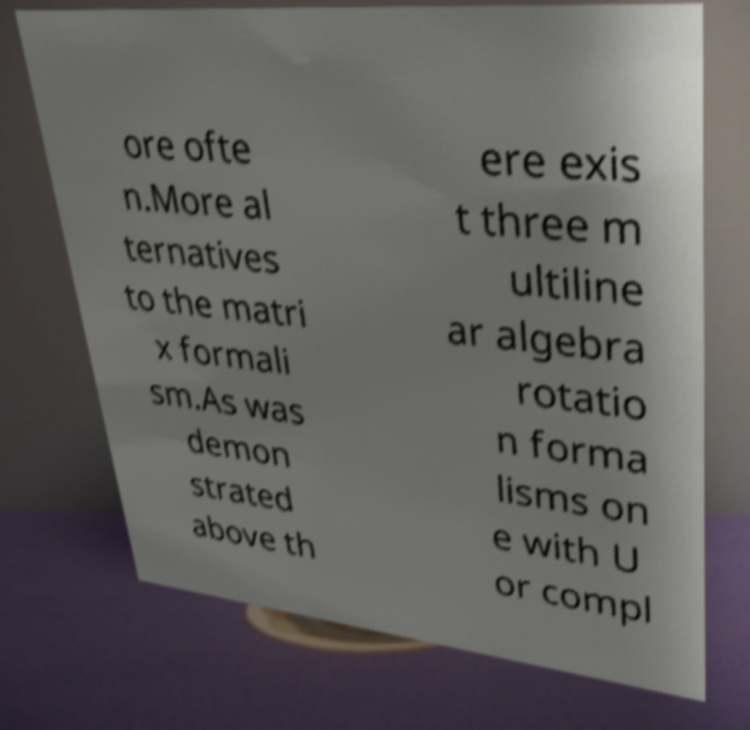Please read and relay the text visible in this image. What does it say? ore ofte n.More al ternatives to the matri x formali sm.As was demon strated above th ere exis t three m ultiline ar algebra rotatio n forma lisms on e with U or compl 